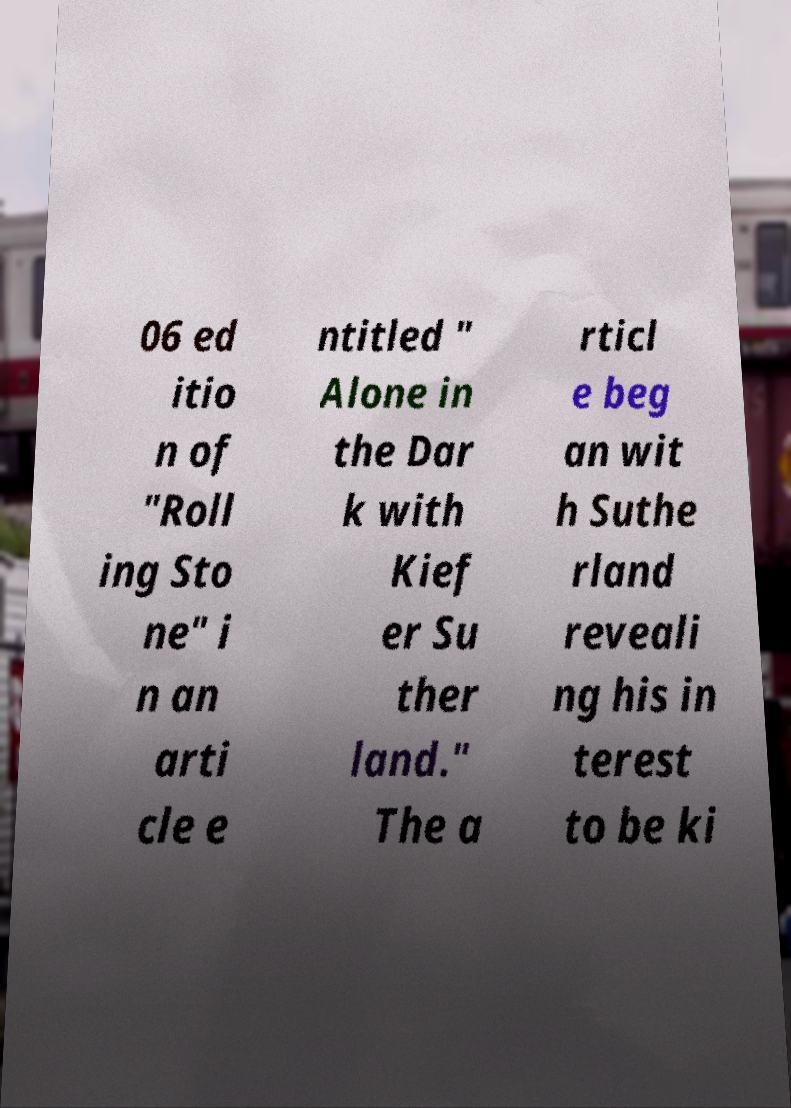Please identify and transcribe the text found in this image. 06 ed itio n of "Roll ing Sto ne" i n an arti cle e ntitled " Alone in the Dar k with Kief er Su ther land." The a rticl e beg an wit h Suthe rland reveali ng his in terest to be ki 